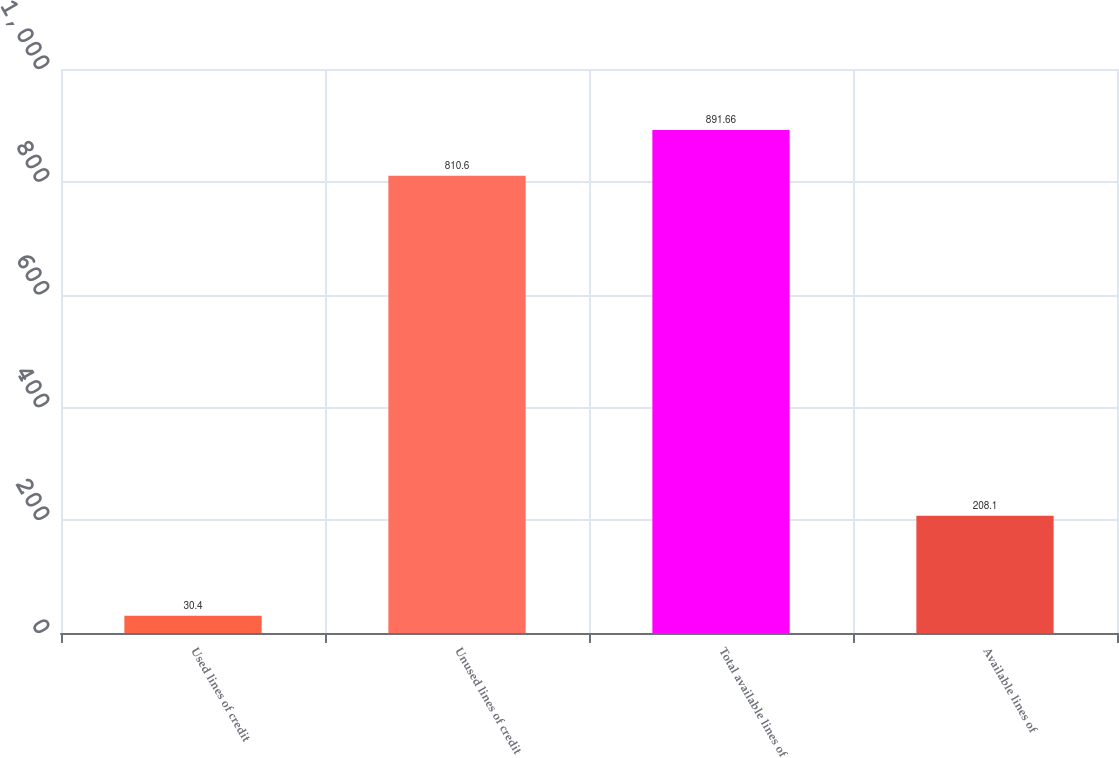Convert chart to OTSL. <chart><loc_0><loc_0><loc_500><loc_500><bar_chart><fcel>Used lines of credit<fcel>Unused lines of credit<fcel>Total available lines of<fcel>Available lines of<nl><fcel>30.4<fcel>810.6<fcel>891.66<fcel>208.1<nl></chart> 